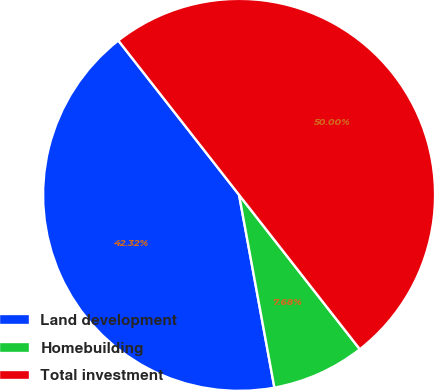Convert chart to OTSL. <chart><loc_0><loc_0><loc_500><loc_500><pie_chart><fcel>Land development<fcel>Homebuilding<fcel>Total investment<nl><fcel>42.32%<fcel>7.68%<fcel>50.0%<nl></chart> 